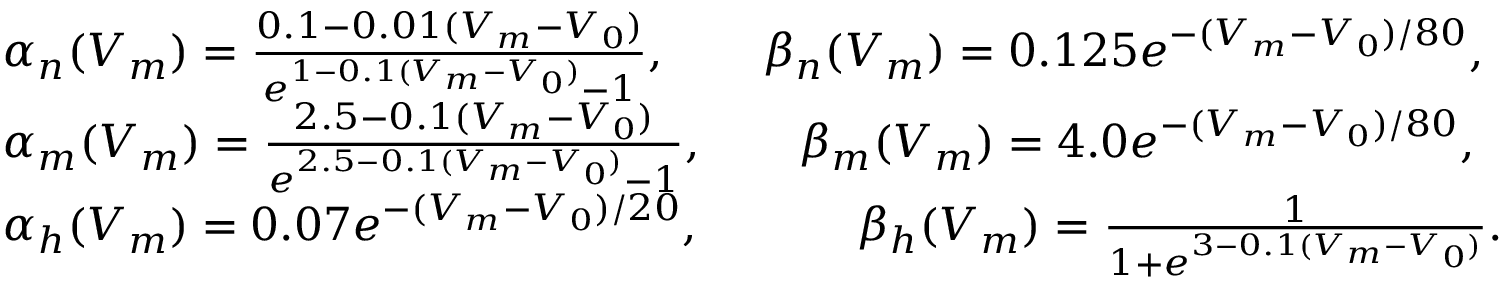<formula> <loc_0><loc_0><loc_500><loc_500>\begin{array} { r l } & { \alpha _ { n } ( V _ { m } ) = \frac { 0 . 1 - 0 . 0 1 ( V _ { m } - V _ { 0 } ) } { e ^ { 1 - 0 . 1 ( V _ { m } - V _ { 0 } ) } - 1 } , \quad \beta _ { n } ( V _ { m } ) = 0 . 1 2 5 e ^ { - ( V _ { m } - V _ { 0 } ) / 8 0 } , } \\ & { \alpha _ { m } ( V _ { m } ) = \frac { 2 . 5 - 0 . 1 ( V _ { m } - V _ { 0 } ) } { e ^ { 2 . 5 - 0 . 1 ( V _ { m } - V _ { 0 } ) } - 1 } , \quad \beta _ { m } ( V _ { m } ) = 4 . 0 e ^ { - ( V _ { m } - V _ { 0 } ) / 8 0 } , } \\ & { \alpha _ { h } ( V _ { m } ) = 0 . 0 7 e ^ { - ( V _ { m } - V _ { 0 } ) / 2 0 } , \quad \beta _ { h } ( V _ { m } ) = \frac { 1 } { 1 + e ^ { 3 - 0 . 1 ( V _ { m } - V _ { 0 } ) } } . } \end{array}</formula> 